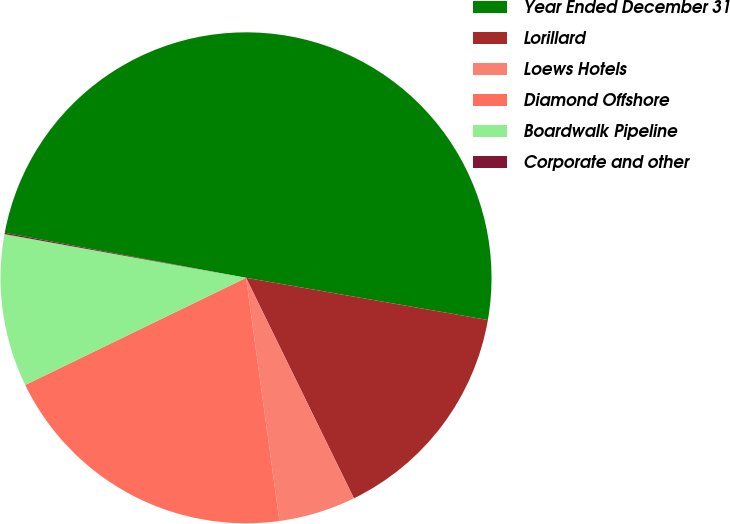Convert chart to OTSL. <chart><loc_0><loc_0><loc_500><loc_500><pie_chart><fcel>Year Ended December 31<fcel>Lorillard<fcel>Loews Hotels<fcel>Diamond Offshore<fcel>Boardwalk Pipeline<fcel>Corporate and other<nl><fcel>49.81%<fcel>15.01%<fcel>5.07%<fcel>19.98%<fcel>10.04%<fcel>0.09%<nl></chart> 